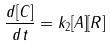Convert formula to latex. <formula><loc_0><loc_0><loc_500><loc_500>\frac { d [ C ] } { d t } = k _ { 2 } [ A ] [ R ]</formula> 